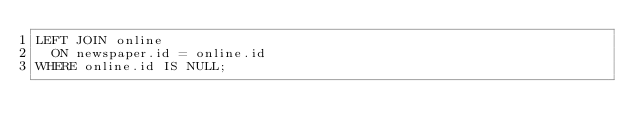<code> <loc_0><loc_0><loc_500><loc_500><_SQL_>LEFT JOIN online
  ON newspaper.id = online.id
WHERE online.id IS NULL;</code> 